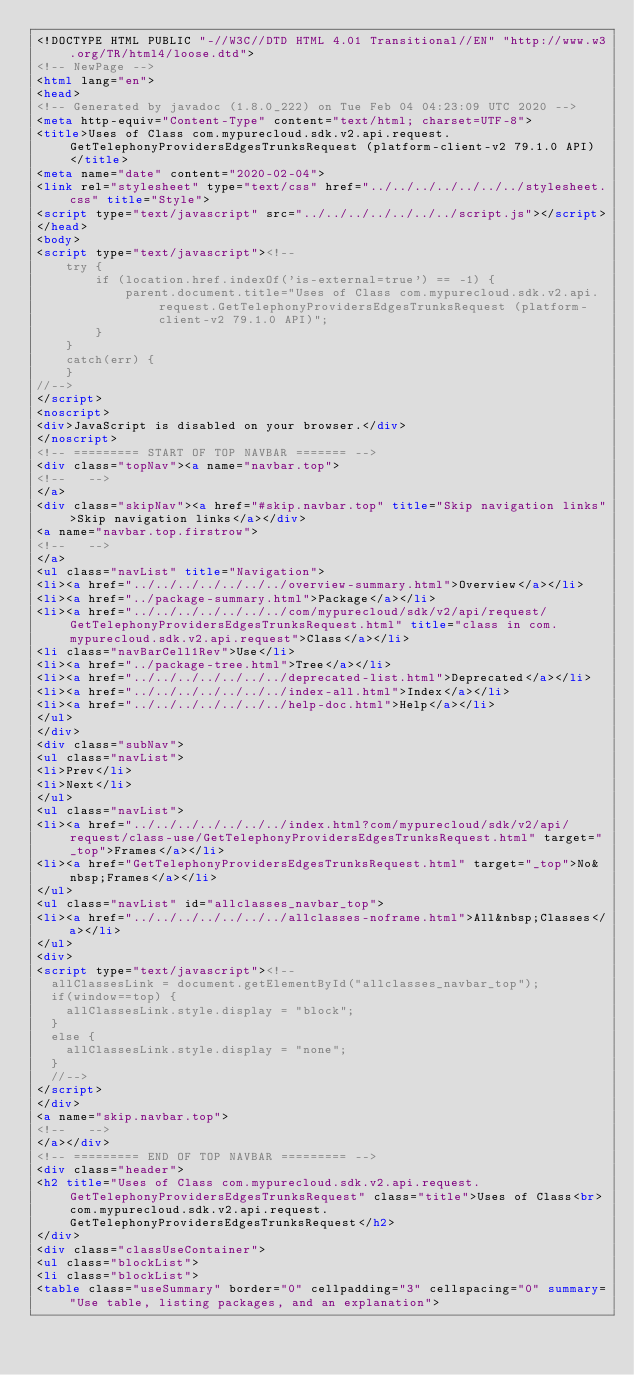Convert code to text. <code><loc_0><loc_0><loc_500><loc_500><_HTML_><!DOCTYPE HTML PUBLIC "-//W3C//DTD HTML 4.01 Transitional//EN" "http://www.w3.org/TR/html4/loose.dtd">
<!-- NewPage -->
<html lang="en">
<head>
<!-- Generated by javadoc (1.8.0_222) on Tue Feb 04 04:23:09 UTC 2020 -->
<meta http-equiv="Content-Type" content="text/html; charset=UTF-8">
<title>Uses of Class com.mypurecloud.sdk.v2.api.request.GetTelephonyProvidersEdgesTrunksRequest (platform-client-v2 79.1.0 API)</title>
<meta name="date" content="2020-02-04">
<link rel="stylesheet" type="text/css" href="../../../../../../../stylesheet.css" title="Style">
<script type="text/javascript" src="../../../../../../../script.js"></script>
</head>
<body>
<script type="text/javascript"><!--
    try {
        if (location.href.indexOf('is-external=true') == -1) {
            parent.document.title="Uses of Class com.mypurecloud.sdk.v2.api.request.GetTelephonyProvidersEdgesTrunksRequest (platform-client-v2 79.1.0 API)";
        }
    }
    catch(err) {
    }
//-->
</script>
<noscript>
<div>JavaScript is disabled on your browser.</div>
</noscript>
<!-- ========= START OF TOP NAVBAR ======= -->
<div class="topNav"><a name="navbar.top">
<!--   -->
</a>
<div class="skipNav"><a href="#skip.navbar.top" title="Skip navigation links">Skip navigation links</a></div>
<a name="navbar.top.firstrow">
<!--   -->
</a>
<ul class="navList" title="Navigation">
<li><a href="../../../../../../../overview-summary.html">Overview</a></li>
<li><a href="../package-summary.html">Package</a></li>
<li><a href="../../../../../../../com/mypurecloud/sdk/v2/api/request/GetTelephonyProvidersEdgesTrunksRequest.html" title="class in com.mypurecloud.sdk.v2.api.request">Class</a></li>
<li class="navBarCell1Rev">Use</li>
<li><a href="../package-tree.html">Tree</a></li>
<li><a href="../../../../../../../deprecated-list.html">Deprecated</a></li>
<li><a href="../../../../../../../index-all.html">Index</a></li>
<li><a href="../../../../../../../help-doc.html">Help</a></li>
</ul>
</div>
<div class="subNav">
<ul class="navList">
<li>Prev</li>
<li>Next</li>
</ul>
<ul class="navList">
<li><a href="../../../../../../../index.html?com/mypurecloud/sdk/v2/api/request/class-use/GetTelephonyProvidersEdgesTrunksRequest.html" target="_top">Frames</a></li>
<li><a href="GetTelephonyProvidersEdgesTrunksRequest.html" target="_top">No&nbsp;Frames</a></li>
</ul>
<ul class="navList" id="allclasses_navbar_top">
<li><a href="../../../../../../../allclasses-noframe.html">All&nbsp;Classes</a></li>
</ul>
<div>
<script type="text/javascript"><!--
  allClassesLink = document.getElementById("allclasses_navbar_top");
  if(window==top) {
    allClassesLink.style.display = "block";
  }
  else {
    allClassesLink.style.display = "none";
  }
  //-->
</script>
</div>
<a name="skip.navbar.top">
<!--   -->
</a></div>
<!-- ========= END OF TOP NAVBAR ========= -->
<div class="header">
<h2 title="Uses of Class com.mypurecloud.sdk.v2.api.request.GetTelephonyProvidersEdgesTrunksRequest" class="title">Uses of Class<br>com.mypurecloud.sdk.v2.api.request.GetTelephonyProvidersEdgesTrunksRequest</h2>
</div>
<div class="classUseContainer">
<ul class="blockList">
<li class="blockList">
<table class="useSummary" border="0" cellpadding="3" cellspacing="0" summary="Use table, listing packages, and an explanation"></code> 